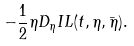Convert formula to latex. <formula><loc_0><loc_0><loc_500><loc_500>- \frac { 1 } { 2 } \eta D _ { \eta } I L ( t , \eta , \bar { \eta } ) .</formula> 